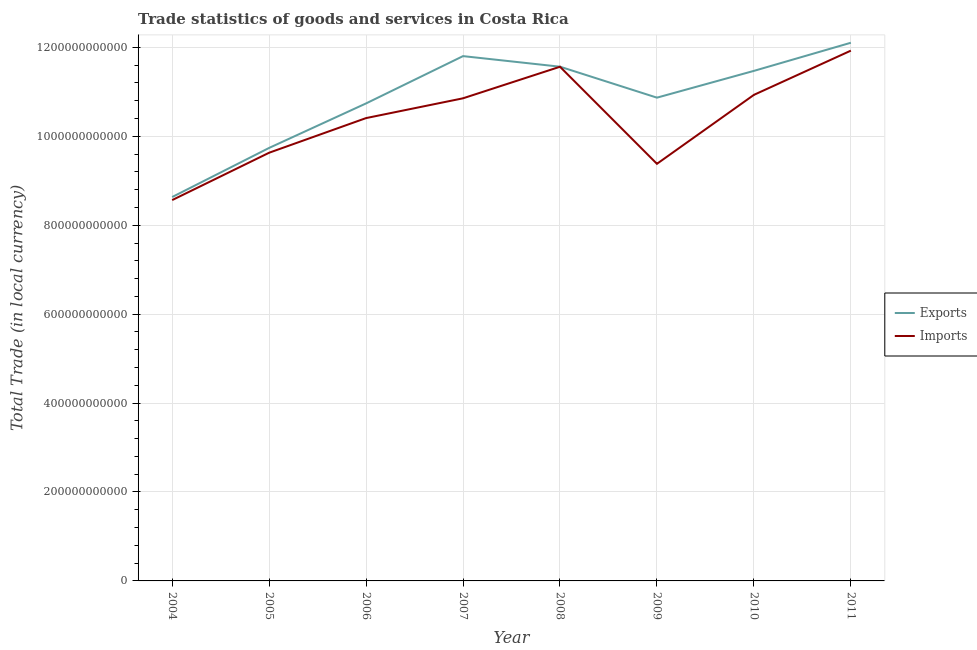What is the export of goods and services in 2011?
Offer a very short reply. 1.21e+12. Across all years, what is the maximum imports of goods and services?
Ensure brevity in your answer.  1.19e+12. Across all years, what is the minimum imports of goods and services?
Offer a very short reply. 8.57e+11. In which year was the imports of goods and services maximum?
Offer a terse response. 2011. In which year was the imports of goods and services minimum?
Provide a short and direct response. 2004. What is the total export of goods and services in the graph?
Ensure brevity in your answer.  8.69e+12. What is the difference between the imports of goods and services in 2005 and that in 2007?
Your answer should be compact. -1.22e+11. What is the difference between the imports of goods and services in 2011 and the export of goods and services in 2004?
Make the answer very short. 3.29e+11. What is the average imports of goods and services per year?
Keep it short and to the point. 1.04e+12. In the year 2007, what is the difference between the export of goods and services and imports of goods and services?
Your answer should be compact. 9.49e+1. What is the ratio of the export of goods and services in 2004 to that in 2005?
Provide a short and direct response. 0.89. Is the difference between the imports of goods and services in 2007 and 2009 greater than the difference between the export of goods and services in 2007 and 2009?
Give a very brief answer. Yes. What is the difference between the highest and the second highest imports of goods and services?
Your answer should be compact. 3.63e+1. What is the difference between the highest and the lowest export of goods and services?
Your answer should be very brief. 3.47e+11. Is the sum of the export of goods and services in 2005 and 2007 greater than the maximum imports of goods and services across all years?
Offer a terse response. Yes. Does the export of goods and services monotonically increase over the years?
Make the answer very short. No. Is the imports of goods and services strictly less than the export of goods and services over the years?
Provide a succinct answer. Yes. How many lines are there?
Provide a succinct answer. 2. What is the difference between two consecutive major ticks on the Y-axis?
Provide a short and direct response. 2.00e+11. Are the values on the major ticks of Y-axis written in scientific E-notation?
Keep it short and to the point. No. Does the graph contain grids?
Your answer should be very brief. Yes. Where does the legend appear in the graph?
Your answer should be very brief. Center right. How are the legend labels stacked?
Your answer should be very brief. Vertical. What is the title of the graph?
Ensure brevity in your answer.  Trade statistics of goods and services in Costa Rica. Does "Domestic liabilities" appear as one of the legend labels in the graph?
Provide a succinct answer. No. What is the label or title of the Y-axis?
Ensure brevity in your answer.  Total Trade (in local currency). What is the Total Trade (in local currency) of Exports in 2004?
Give a very brief answer. 8.63e+11. What is the Total Trade (in local currency) of Imports in 2004?
Ensure brevity in your answer.  8.57e+11. What is the Total Trade (in local currency) of Exports in 2005?
Provide a short and direct response. 9.74e+11. What is the Total Trade (in local currency) in Imports in 2005?
Your answer should be compact. 9.63e+11. What is the Total Trade (in local currency) in Exports in 2006?
Give a very brief answer. 1.07e+12. What is the Total Trade (in local currency) in Imports in 2006?
Keep it short and to the point. 1.04e+12. What is the Total Trade (in local currency) of Exports in 2007?
Your answer should be very brief. 1.18e+12. What is the Total Trade (in local currency) of Imports in 2007?
Give a very brief answer. 1.09e+12. What is the Total Trade (in local currency) in Exports in 2008?
Your answer should be compact. 1.16e+12. What is the Total Trade (in local currency) of Imports in 2008?
Your answer should be compact. 1.16e+12. What is the Total Trade (in local currency) in Exports in 2009?
Your answer should be very brief. 1.09e+12. What is the Total Trade (in local currency) of Imports in 2009?
Your response must be concise. 9.38e+11. What is the Total Trade (in local currency) in Exports in 2010?
Your answer should be very brief. 1.15e+12. What is the Total Trade (in local currency) of Imports in 2010?
Your response must be concise. 1.09e+12. What is the Total Trade (in local currency) in Exports in 2011?
Provide a succinct answer. 1.21e+12. What is the Total Trade (in local currency) of Imports in 2011?
Your response must be concise. 1.19e+12. Across all years, what is the maximum Total Trade (in local currency) of Exports?
Offer a terse response. 1.21e+12. Across all years, what is the maximum Total Trade (in local currency) of Imports?
Your response must be concise. 1.19e+12. Across all years, what is the minimum Total Trade (in local currency) in Exports?
Offer a terse response. 8.63e+11. Across all years, what is the minimum Total Trade (in local currency) of Imports?
Your answer should be compact. 8.57e+11. What is the total Total Trade (in local currency) in Exports in the graph?
Provide a succinct answer. 8.69e+12. What is the total Total Trade (in local currency) of Imports in the graph?
Offer a very short reply. 8.33e+12. What is the difference between the Total Trade (in local currency) in Exports in 2004 and that in 2005?
Ensure brevity in your answer.  -1.10e+11. What is the difference between the Total Trade (in local currency) of Imports in 2004 and that in 2005?
Your answer should be compact. -1.07e+11. What is the difference between the Total Trade (in local currency) of Exports in 2004 and that in 2006?
Provide a succinct answer. -2.11e+11. What is the difference between the Total Trade (in local currency) in Imports in 2004 and that in 2006?
Your response must be concise. -1.84e+11. What is the difference between the Total Trade (in local currency) in Exports in 2004 and that in 2007?
Your response must be concise. -3.17e+11. What is the difference between the Total Trade (in local currency) in Imports in 2004 and that in 2007?
Give a very brief answer. -2.29e+11. What is the difference between the Total Trade (in local currency) in Exports in 2004 and that in 2008?
Provide a succinct answer. -2.93e+11. What is the difference between the Total Trade (in local currency) in Imports in 2004 and that in 2008?
Your answer should be compact. -3.00e+11. What is the difference between the Total Trade (in local currency) of Exports in 2004 and that in 2009?
Offer a very short reply. -2.24e+11. What is the difference between the Total Trade (in local currency) of Imports in 2004 and that in 2009?
Ensure brevity in your answer.  -8.16e+1. What is the difference between the Total Trade (in local currency) in Exports in 2004 and that in 2010?
Provide a short and direct response. -2.84e+11. What is the difference between the Total Trade (in local currency) of Imports in 2004 and that in 2010?
Your answer should be compact. -2.37e+11. What is the difference between the Total Trade (in local currency) of Exports in 2004 and that in 2011?
Keep it short and to the point. -3.47e+11. What is the difference between the Total Trade (in local currency) of Imports in 2004 and that in 2011?
Your answer should be very brief. -3.36e+11. What is the difference between the Total Trade (in local currency) in Exports in 2005 and that in 2006?
Your answer should be very brief. -1.00e+11. What is the difference between the Total Trade (in local currency) of Imports in 2005 and that in 2006?
Make the answer very short. -7.79e+1. What is the difference between the Total Trade (in local currency) in Exports in 2005 and that in 2007?
Offer a terse response. -2.06e+11. What is the difference between the Total Trade (in local currency) of Imports in 2005 and that in 2007?
Your answer should be very brief. -1.22e+11. What is the difference between the Total Trade (in local currency) in Exports in 2005 and that in 2008?
Keep it short and to the point. -1.83e+11. What is the difference between the Total Trade (in local currency) in Imports in 2005 and that in 2008?
Provide a short and direct response. -1.93e+11. What is the difference between the Total Trade (in local currency) of Exports in 2005 and that in 2009?
Your response must be concise. -1.13e+11. What is the difference between the Total Trade (in local currency) in Imports in 2005 and that in 2009?
Your answer should be compact. 2.49e+1. What is the difference between the Total Trade (in local currency) in Exports in 2005 and that in 2010?
Make the answer very short. -1.73e+11. What is the difference between the Total Trade (in local currency) in Imports in 2005 and that in 2010?
Make the answer very short. -1.30e+11. What is the difference between the Total Trade (in local currency) in Exports in 2005 and that in 2011?
Your answer should be very brief. -2.37e+11. What is the difference between the Total Trade (in local currency) in Imports in 2005 and that in 2011?
Make the answer very short. -2.30e+11. What is the difference between the Total Trade (in local currency) in Exports in 2006 and that in 2007?
Offer a very short reply. -1.06e+11. What is the difference between the Total Trade (in local currency) of Imports in 2006 and that in 2007?
Keep it short and to the point. -4.45e+1. What is the difference between the Total Trade (in local currency) in Exports in 2006 and that in 2008?
Your answer should be very brief. -8.26e+1. What is the difference between the Total Trade (in local currency) of Imports in 2006 and that in 2008?
Your answer should be very brief. -1.15e+11. What is the difference between the Total Trade (in local currency) in Exports in 2006 and that in 2009?
Your response must be concise. -1.30e+1. What is the difference between the Total Trade (in local currency) in Imports in 2006 and that in 2009?
Your response must be concise. 1.03e+11. What is the difference between the Total Trade (in local currency) of Exports in 2006 and that in 2010?
Your response must be concise. -7.32e+1. What is the difference between the Total Trade (in local currency) in Imports in 2006 and that in 2010?
Your response must be concise. -5.22e+1. What is the difference between the Total Trade (in local currency) in Exports in 2006 and that in 2011?
Ensure brevity in your answer.  -1.36e+11. What is the difference between the Total Trade (in local currency) of Imports in 2006 and that in 2011?
Your answer should be very brief. -1.52e+11. What is the difference between the Total Trade (in local currency) in Exports in 2007 and that in 2008?
Make the answer very short. 2.38e+1. What is the difference between the Total Trade (in local currency) in Imports in 2007 and that in 2008?
Offer a very short reply. -7.10e+1. What is the difference between the Total Trade (in local currency) in Exports in 2007 and that in 2009?
Your response must be concise. 9.34e+1. What is the difference between the Total Trade (in local currency) of Imports in 2007 and that in 2009?
Your answer should be very brief. 1.47e+11. What is the difference between the Total Trade (in local currency) in Exports in 2007 and that in 2010?
Offer a very short reply. 3.32e+1. What is the difference between the Total Trade (in local currency) of Imports in 2007 and that in 2010?
Your answer should be compact. -7.72e+09. What is the difference between the Total Trade (in local currency) of Exports in 2007 and that in 2011?
Offer a terse response. -3.01e+1. What is the difference between the Total Trade (in local currency) of Imports in 2007 and that in 2011?
Your answer should be compact. -1.07e+11. What is the difference between the Total Trade (in local currency) in Exports in 2008 and that in 2009?
Give a very brief answer. 6.96e+1. What is the difference between the Total Trade (in local currency) of Imports in 2008 and that in 2009?
Your answer should be compact. 2.18e+11. What is the difference between the Total Trade (in local currency) of Exports in 2008 and that in 2010?
Provide a short and direct response. 9.41e+09. What is the difference between the Total Trade (in local currency) in Imports in 2008 and that in 2010?
Provide a short and direct response. 6.32e+1. What is the difference between the Total Trade (in local currency) in Exports in 2008 and that in 2011?
Ensure brevity in your answer.  -5.39e+1. What is the difference between the Total Trade (in local currency) in Imports in 2008 and that in 2011?
Give a very brief answer. -3.63e+1. What is the difference between the Total Trade (in local currency) of Exports in 2009 and that in 2010?
Make the answer very short. -6.02e+1. What is the difference between the Total Trade (in local currency) of Imports in 2009 and that in 2010?
Provide a succinct answer. -1.55e+11. What is the difference between the Total Trade (in local currency) in Exports in 2009 and that in 2011?
Your answer should be very brief. -1.24e+11. What is the difference between the Total Trade (in local currency) in Imports in 2009 and that in 2011?
Offer a very short reply. -2.55e+11. What is the difference between the Total Trade (in local currency) in Exports in 2010 and that in 2011?
Your answer should be very brief. -6.33e+1. What is the difference between the Total Trade (in local currency) in Imports in 2010 and that in 2011?
Provide a succinct answer. -9.95e+1. What is the difference between the Total Trade (in local currency) in Exports in 2004 and the Total Trade (in local currency) in Imports in 2005?
Offer a terse response. -9.96e+1. What is the difference between the Total Trade (in local currency) of Exports in 2004 and the Total Trade (in local currency) of Imports in 2006?
Offer a very short reply. -1.78e+11. What is the difference between the Total Trade (in local currency) of Exports in 2004 and the Total Trade (in local currency) of Imports in 2007?
Provide a short and direct response. -2.22e+11. What is the difference between the Total Trade (in local currency) of Exports in 2004 and the Total Trade (in local currency) of Imports in 2008?
Give a very brief answer. -2.93e+11. What is the difference between the Total Trade (in local currency) of Exports in 2004 and the Total Trade (in local currency) of Imports in 2009?
Your answer should be very brief. -7.47e+1. What is the difference between the Total Trade (in local currency) of Exports in 2004 and the Total Trade (in local currency) of Imports in 2010?
Provide a short and direct response. -2.30e+11. What is the difference between the Total Trade (in local currency) of Exports in 2004 and the Total Trade (in local currency) of Imports in 2011?
Your response must be concise. -3.29e+11. What is the difference between the Total Trade (in local currency) of Exports in 2005 and the Total Trade (in local currency) of Imports in 2006?
Offer a very short reply. -6.71e+1. What is the difference between the Total Trade (in local currency) in Exports in 2005 and the Total Trade (in local currency) in Imports in 2007?
Offer a terse response. -1.12e+11. What is the difference between the Total Trade (in local currency) in Exports in 2005 and the Total Trade (in local currency) in Imports in 2008?
Provide a succinct answer. -1.83e+11. What is the difference between the Total Trade (in local currency) of Exports in 2005 and the Total Trade (in local currency) of Imports in 2009?
Keep it short and to the point. 3.57e+1. What is the difference between the Total Trade (in local currency) of Exports in 2005 and the Total Trade (in local currency) of Imports in 2010?
Ensure brevity in your answer.  -1.19e+11. What is the difference between the Total Trade (in local currency) in Exports in 2005 and the Total Trade (in local currency) in Imports in 2011?
Your answer should be very brief. -2.19e+11. What is the difference between the Total Trade (in local currency) of Exports in 2006 and the Total Trade (in local currency) of Imports in 2007?
Give a very brief answer. -1.15e+1. What is the difference between the Total Trade (in local currency) of Exports in 2006 and the Total Trade (in local currency) of Imports in 2008?
Keep it short and to the point. -8.25e+1. What is the difference between the Total Trade (in local currency) in Exports in 2006 and the Total Trade (in local currency) in Imports in 2009?
Your answer should be very brief. 1.36e+11. What is the difference between the Total Trade (in local currency) of Exports in 2006 and the Total Trade (in local currency) of Imports in 2010?
Keep it short and to the point. -1.92e+1. What is the difference between the Total Trade (in local currency) of Exports in 2006 and the Total Trade (in local currency) of Imports in 2011?
Your response must be concise. -1.19e+11. What is the difference between the Total Trade (in local currency) of Exports in 2007 and the Total Trade (in local currency) of Imports in 2008?
Make the answer very short. 2.39e+1. What is the difference between the Total Trade (in local currency) of Exports in 2007 and the Total Trade (in local currency) of Imports in 2009?
Keep it short and to the point. 2.42e+11. What is the difference between the Total Trade (in local currency) in Exports in 2007 and the Total Trade (in local currency) in Imports in 2010?
Give a very brief answer. 8.72e+1. What is the difference between the Total Trade (in local currency) of Exports in 2007 and the Total Trade (in local currency) of Imports in 2011?
Your response must be concise. -1.23e+1. What is the difference between the Total Trade (in local currency) of Exports in 2008 and the Total Trade (in local currency) of Imports in 2009?
Your answer should be compact. 2.18e+11. What is the difference between the Total Trade (in local currency) in Exports in 2008 and the Total Trade (in local currency) in Imports in 2010?
Give a very brief answer. 6.34e+1. What is the difference between the Total Trade (in local currency) in Exports in 2008 and the Total Trade (in local currency) in Imports in 2011?
Your answer should be very brief. -3.61e+1. What is the difference between the Total Trade (in local currency) in Exports in 2009 and the Total Trade (in local currency) in Imports in 2010?
Ensure brevity in your answer.  -6.26e+09. What is the difference between the Total Trade (in local currency) in Exports in 2009 and the Total Trade (in local currency) in Imports in 2011?
Offer a very short reply. -1.06e+11. What is the difference between the Total Trade (in local currency) of Exports in 2010 and the Total Trade (in local currency) of Imports in 2011?
Make the answer very short. -4.55e+1. What is the average Total Trade (in local currency) of Exports per year?
Your answer should be very brief. 1.09e+12. What is the average Total Trade (in local currency) in Imports per year?
Provide a short and direct response. 1.04e+12. In the year 2004, what is the difference between the Total Trade (in local currency) in Exports and Total Trade (in local currency) in Imports?
Ensure brevity in your answer.  6.89e+09. In the year 2005, what is the difference between the Total Trade (in local currency) of Exports and Total Trade (in local currency) of Imports?
Ensure brevity in your answer.  1.08e+1. In the year 2006, what is the difference between the Total Trade (in local currency) in Exports and Total Trade (in local currency) in Imports?
Your answer should be very brief. 3.30e+1. In the year 2007, what is the difference between the Total Trade (in local currency) of Exports and Total Trade (in local currency) of Imports?
Your answer should be very brief. 9.49e+1. In the year 2008, what is the difference between the Total Trade (in local currency) of Exports and Total Trade (in local currency) of Imports?
Your answer should be compact. 1.31e+08. In the year 2009, what is the difference between the Total Trade (in local currency) in Exports and Total Trade (in local currency) in Imports?
Offer a terse response. 1.49e+11. In the year 2010, what is the difference between the Total Trade (in local currency) in Exports and Total Trade (in local currency) in Imports?
Offer a terse response. 5.40e+1. In the year 2011, what is the difference between the Total Trade (in local currency) of Exports and Total Trade (in local currency) of Imports?
Offer a terse response. 1.77e+1. What is the ratio of the Total Trade (in local currency) in Exports in 2004 to that in 2005?
Your answer should be compact. 0.89. What is the ratio of the Total Trade (in local currency) in Imports in 2004 to that in 2005?
Provide a short and direct response. 0.89. What is the ratio of the Total Trade (in local currency) in Exports in 2004 to that in 2006?
Provide a short and direct response. 0.8. What is the ratio of the Total Trade (in local currency) in Imports in 2004 to that in 2006?
Provide a short and direct response. 0.82. What is the ratio of the Total Trade (in local currency) in Exports in 2004 to that in 2007?
Your answer should be very brief. 0.73. What is the ratio of the Total Trade (in local currency) in Imports in 2004 to that in 2007?
Give a very brief answer. 0.79. What is the ratio of the Total Trade (in local currency) in Exports in 2004 to that in 2008?
Provide a succinct answer. 0.75. What is the ratio of the Total Trade (in local currency) of Imports in 2004 to that in 2008?
Offer a very short reply. 0.74. What is the ratio of the Total Trade (in local currency) in Exports in 2004 to that in 2009?
Your answer should be compact. 0.79. What is the ratio of the Total Trade (in local currency) of Imports in 2004 to that in 2009?
Provide a succinct answer. 0.91. What is the ratio of the Total Trade (in local currency) in Exports in 2004 to that in 2010?
Offer a very short reply. 0.75. What is the ratio of the Total Trade (in local currency) of Imports in 2004 to that in 2010?
Give a very brief answer. 0.78. What is the ratio of the Total Trade (in local currency) in Exports in 2004 to that in 2011?
Provide a succinct answer. 0.71. What is the ratio of the Total Trade (in local currency) in Imports in 2004 to that in 2011?
Give a very brief answer. 0.72. What is the ratio of the Total Trade (in local currency) of Exports in 2005 to that in 2006?
Make the answer very short. 0.91. What is the ratio of the Total Trade (in local currency) in Imports in 2005 to that in 2006?
Give a very brief answer. 0.93. What is the ratio of the Total Trade (in local currency) in Exports in 2005 to that in 2007?
Your answer should be compact. 0.83. What is the ratio of the Total Trade (in local currency) of Imports in 2005 to that in 2007?
Keep it short and to the point. 0.89. What is the ratio of the Total Trade (in local currency) of Exports in 2005 to that in 2008?
Keep it short and to the point. 0.84. What is the ratio of the Total Trade (in local currency) in Imports in 2005 to that in 2008?
Provide a succinct answer. 0.83. What is the ratio of the Total Trade (in local currency) in Exports in 2005 to that in 2009?
Ensure brevity in your answer.  0.9. What is the ratio of the Total Trade (in local currency) of Imports in 2005 to that in 2009?
Offer a terse response. 1.03. What is the ratio of the Total Trade (in local currency) in Exports in 2005 to that in 2010?
Offer a very short reply. 0.85. What is the ratio of the Total Trade (in local currency) in Imports in 2005 to that in 2010?
Give a very brief answer. 0.88. What is the ratio of the Total Trade (in local currency) of Exports in 2005 to that in 2011?
Ensure brevity in your answer.  0.8. What is the ratio of the Total Trade (in local currency) of Imports in 2005 to that in 2011?
Your response must be concise. 0.81. What is the ratio of the Total Trade (in local currency) in Exports in 2006 to that in 2007?
Offer a terse response. 0.91. What is the ratio of the Total Trade (in local currency) in Imports in 2006 to that in 2007?
Provide a short and direct response. 0.96. What is the ratio of the Total Trade (in local currency) in Exports in 2006 to that in 2008?
Give a very brief answer. 0.93. What is the ratio of the Total Trade (in local currency) of Imports in 2006 to that in 2008?
Offer a very short reply. 0.9. What is the ratio of the Total Trade (in local currency) in Exports in 2006 to that in 2009?
Offer a very short reply. 0.99. What is the ratio of the Total Trade (in local currency) of Imports in 2006 to that in 2009?
Your answer should be compact. 1.11. What is the ratio of the Total Trade (in local currency) in Exports in 2006 to that in 2010?
Your answer should be very brief. 0.94. What is the ratio of the Total Trade (in local currency) in Imports in 2006 to that in 2010?
Provide a short and direct response. 0.95. What is the ratio of the Total Trade (in local currency) of Exports in 2006 to that in 2011?
Your answer should be very brief. 0.89. What is the ratio of the Total Trade (in local currency) of Imports in 2006 to that in 2011?
Your response must be concise. 0.87. What is the ratio of the Total Trade (in local currency) of Exports in 2007 to that in 2008?
Offer a very short reply. 1.02. What is the ratio of the Total Trade (in local currency) in Imports in 2007 to that in 2008?
Give a very brief answer. 0.94. What is the ratio of the Total Trade (in local currency) of Exports in 2007 to that in 2009?
Offer a terse response. 1.09. What is the ratio of the Total Trade (in local currency) of Imports in 2007 to that in 2009?
Offer a very short reply. 1.16. What is the ratio of the Total Trade (in local currency) of Exports in 2007 to that in 2010?
Keep it short and to the point. 1.03. What is the ratio of the Total Trade (in local currency) of Exports in 2007 to that in 2011?
Keep it short and to the point. 0.98. What is the ratio of the Total Trade (in local currency) in Imports in 2007 to that in 2011?
Give a very brief answer. 0.91. What is the ratio of the Total Trade (in local currency) of Exports in 2008 to that in 2009?
Provide a succinct answer. 1.06. What is the ratio of the Total Trade (in local currency) in Imports in 2008 to that in 2009?
Give a very brief answer. 1.23. What is the ratio of the Total Trade (in local currency) of Exports in 2008 to that in 2010?
Provide a short and direct response. 1.01. What is the ratio of the Total Trade (in local currency) of Imports in 2008 to that in 2010?
Offer a very short reply. 1.06. What is the ratio of the Total Trade (in local currency) of Exports in 2008 to that in 2011?
Make the answer very short. 0.96. What is the ratio of the Total Trade (in local currency) in Imports in 2008 to that in 2011?
Provide a short and direct response. 0.97. What is the ratio of the Total Trade (in local currency) in Exports in 2009 to that in 2010?
Make the answer very short. 0.95. What is the ratio of the Total Trade (in local currency) of Imports in 2009 to that in 2010?
Your answer should be very brief. 0.86. What is the ratio of the Total Trade (in local currency) in Exports in 2009 to that in 2011?
Your answer should be very brief. 0.9. What is the ratio of the Total Trade (in local currency) of Imports in 2009 to that in 2011?
Keep it short and to the point. 0.79. What is the ratio of the Total Trade (in local currency) of Exports in 2010 to that in 2011?
Ensure brevity in your answer.  0.95. What is the ratio of the Total Trade (in local currency) in Imports in 2010 to that in 2011?
Keep it short and to the point. 0.92. What is the difference between the highest and the second highest Total Trade (in local currency) of Exports?
Offer a very short reply. 3.01e+1. What is the difference between the highest and the second highest Total Trade (in local currency) of Imports?
Your response must be concise. 3.63e+1. What is the difference between the highest and the lowest Total Trade (in local currency) in Exports?
Ensure brevity in your answer.  3.47e+11. What is the difference between the highest and the lowest Total Trade (in local currency) of Imports?
Give a very brief answer. 3.36e+11. 